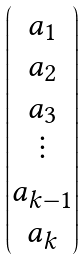<formula> <loc_0><loc_0><loc_500><loc_500>\begin{pmatrix} a _ { 1 } \\ a _ { 2 } \\ a _ { 3 } \\ \vdots \\ a _ { k - 1 } \\ a _ { k } \end{pmatrix}</formula> 